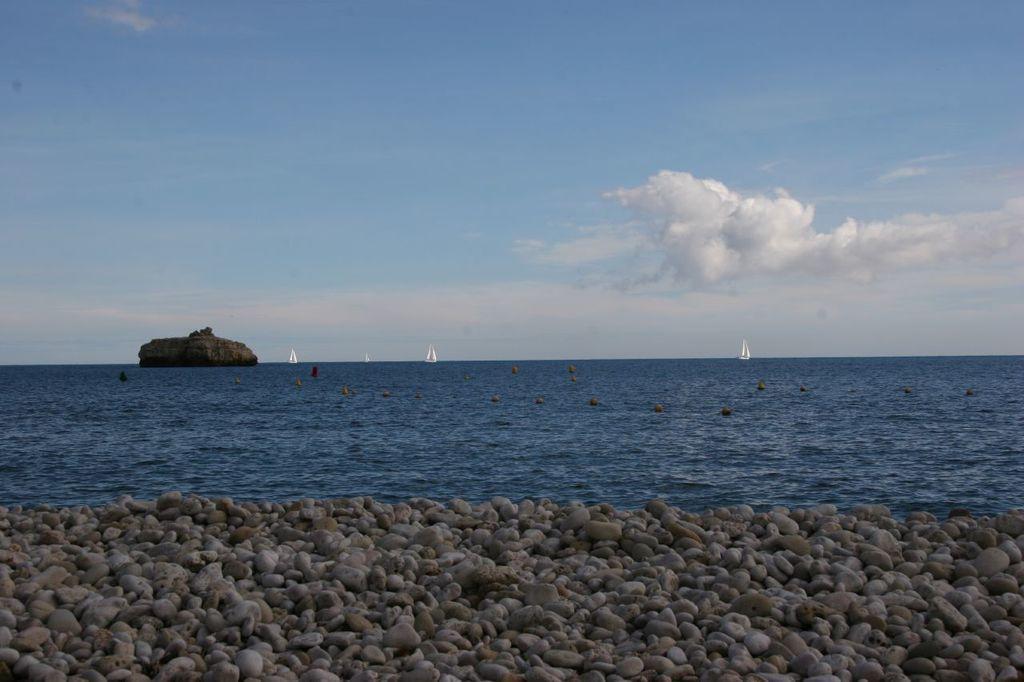Could you give a brief overview of what you see in this image? As we can see in the image there is water, boats, stones, sky and clouds. 